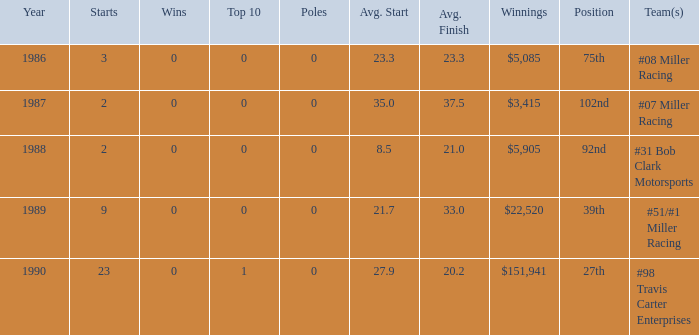How many teams ended in the top group with an average finish of 2 1.0. 